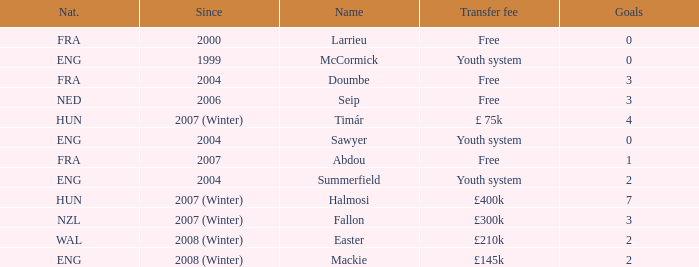What is the average goals Sawyer has? 0.0. 